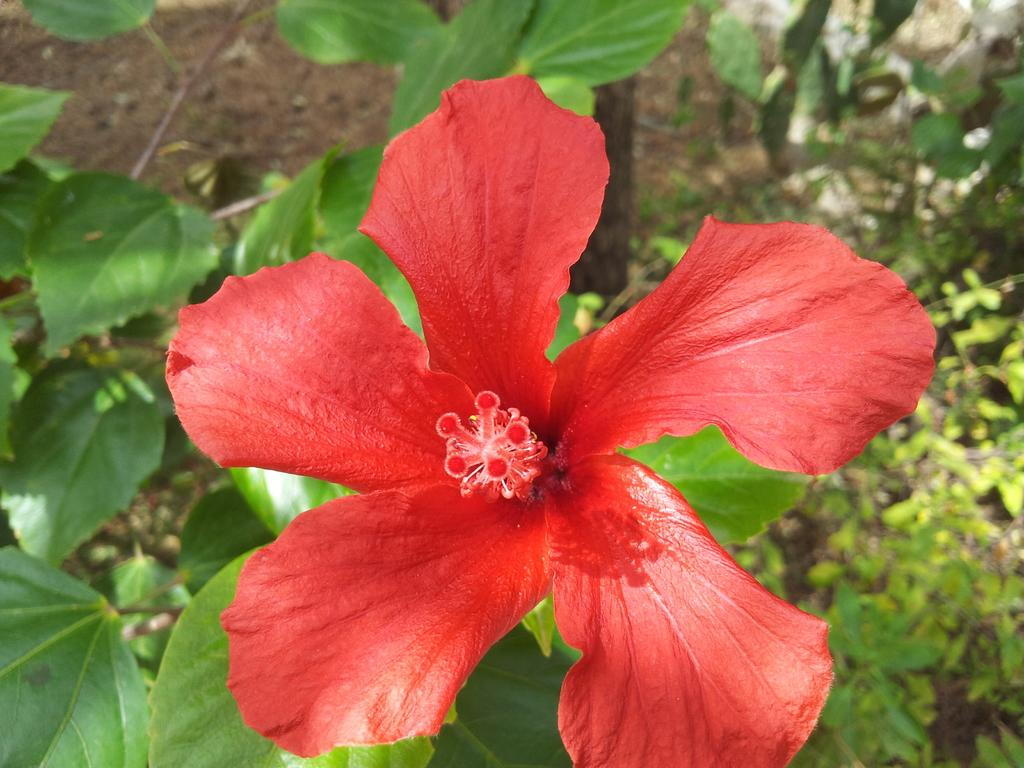What type of living organisms can be seen in the image? Plants can be seen in the image. Can you describe any specific features of the plants? There is a flower on one of the plants. What type of oil can be seen dripping from the flower in the image? There is no oil present in the image, and the flower is not depicted as dripping anything. 